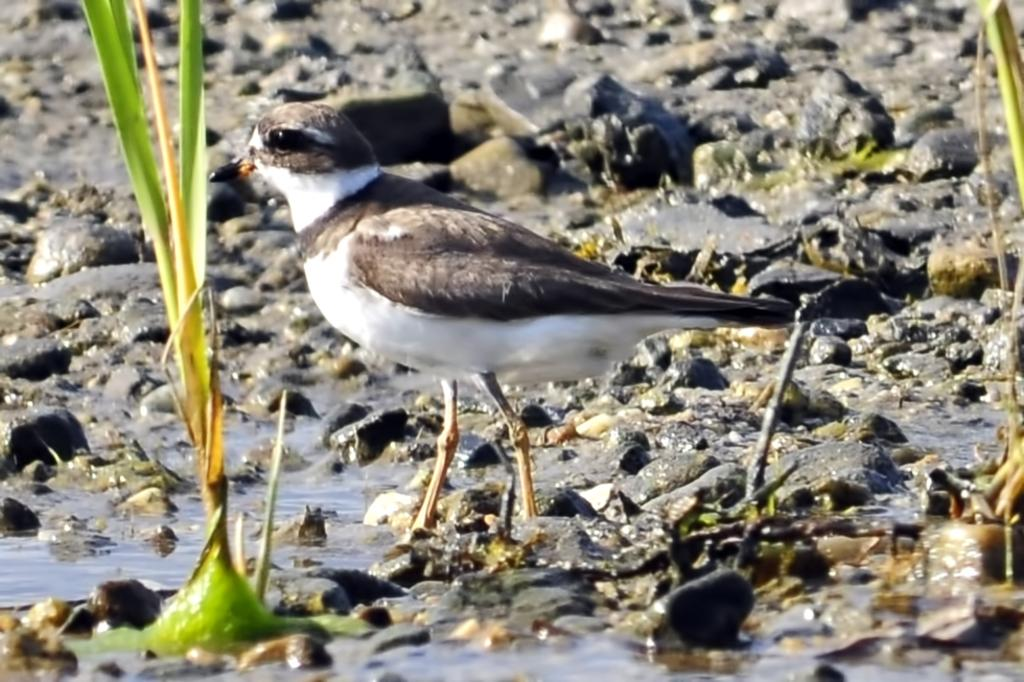What type of animal can be seen in the image? There is a bird in the image. Where is the bird located in the image? The bird is standing on the ground. What type of vegetation is present in the image? Grass is present in the image. What can be seen besides the bird and grass in the image? There is water visible in the image. What type of landscape feature can be seen in the background of the image? Stones are present in the background of the image. How does the bird increase its knowledge in the image? The image does not show the bird learning or increasing its knowledge; it simply depicts the bird standing on the ground. 